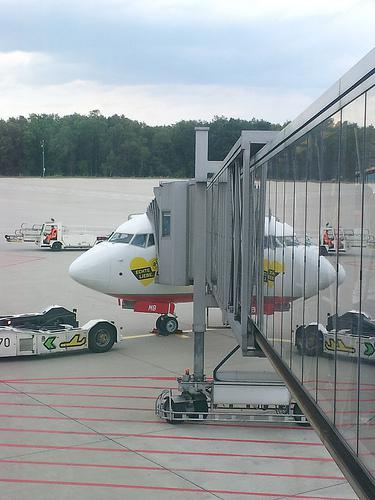Question: what color are the parking lot lines?
Choices:
A. Red.
B. White.
C. Blue.
D. Yellow.
Answer with the letter. Answer: A Question: what color is the heart on the plane?
Choices:
A. Red.
B. Yellow.
C. Orange.
D. Blue.
Answer with the letter. Answer: B Question: when was picture taken?
Choices:
A. Morning.
B. A week ago.
C. Evening.
D. 2 hours ago.
Answer with the letter. Answer: C Question: why is bottom of plane open?
Choices:
A. Storage.
B. Food.
C. Luggage.
D. Engine.
Answer with the letter. Answer: C Question: where was picture taken?
Choices:
A. In car.
B. Far from plane.
C. Near plane.
D. In the building.
Answer with the letter. Answer: C 